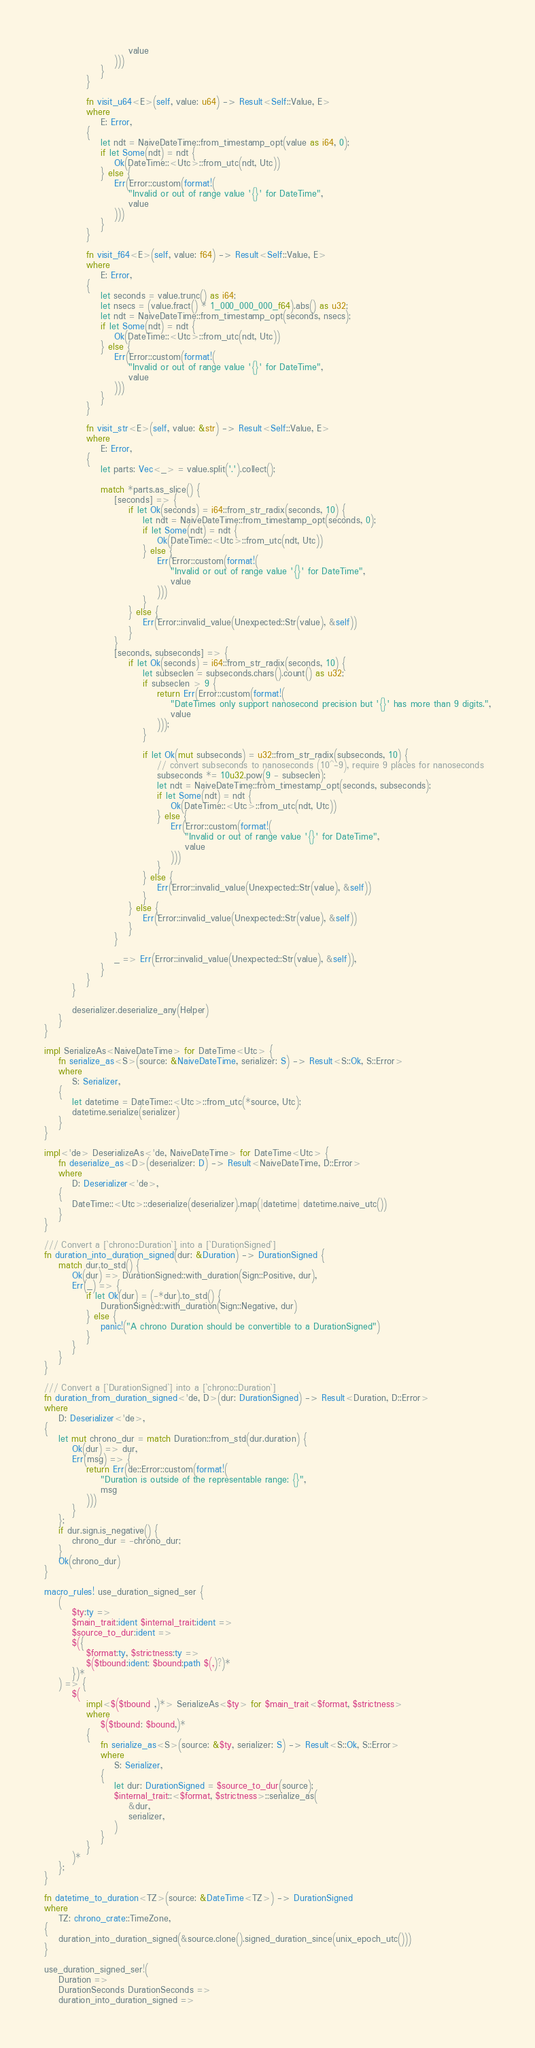<code> <loc_0><loc_0><loc_500><loc_500><_Rust_>                        value
                    )))
                }
            }

            fn visit_u64<E>(self, value: u64) -> Result<Self::Value, E>
            where
                E: Error,
            {
                let ndt = NaiveDateTime::from_timestamp_opt(value as i64, 0);
                if let Some(ndt) = ndt {
                    Ok(DateTime::<Utc>::from_utc(ndt, Utc))
                } else {
                    Err(Error::custom(format!(
                        "Invalid or out of range value '{}' for DateTime",
                        value
                    )))
                }
            }

            fn visit_f64<E>(self, value: f64) -> Result<Self::Value, E>
            where
                E: Error,
            {
                let seconds = value.trunc() as i64;
                let nsecs = (value.fract() * 1_000_000_000_f64).abs() as u32;
                let ndt = NaiveDateTime::from_timestamp_opt(seconds, nsecs);
                if let Some(ndt) = ndt {
                    Ok(DateTime::<Utc>::from_utc(ndt, Utc))
                } else {
                    Err(Error::custom(format!(
                        "Invalid or out of range value '{}' for DateTime",
                        value
                    )))
                }
            }

            fn visit_str<E>(self, value: &str) -> Result<Self::Value, E>
            where
                E: Error,
            {
                let parts: Vec<_> = value.split('.').collect();

                match *parts.as_slice() {
                    [seconds] => {
                        if let Ok(seconds) = i64::from_str_radix(seconds, 10) {
                            let ndt = NaiveDateTime::from_timestamp_opt(seconds, 0);
                            if let Some(ndt) = ndt {
                                Ok(DateTime::<Utc>::from_utc(ndt, Utc))
                            } else {
                                Err(Error::custom(format!(
                                    "Invalid or out of range value '{}' for DateTime",
                                    value
                                )))
                            }
                        } else {
                            Err(Error::invalid_value(Unexpected::Str(value), &self))
                        }
                    }
                    [seconds, subseconds] => {
                        if let Ok(seconds) = i64::from_str_radix(seconds, 10) {
                            let subseclen = subseconds.chars().count() as u32;
                            if subseclen > 9 {
                                return Err(Error::custom(format!(
                                    "DateTimes only support nanosecond precision but '{}' has more than 9 digits.",
                                    value
                                )));
                            }

                            if let Ok(mut subseconds) = u32::from_str_radix(subseconds, 10) {
                                // convert subseconds to nanoseconds (10^-9), require 9 places for nanoseconds
                                subseconds *= 10u32.pow(9 - subseclen);
                                let ndt = NaiveDateTime::from_timestamp_opt(seconds, subseconds);
                                if let Some(ndt) = ndt {
                                    Ok(DateTime::<Utc>::from_utc(ndt, Utc))
                                } else {
                                    Err(Error::custom(format!(
                                        "Invalid or out of range value '{}' for DateTime",
                                        value
                                    )))
                                }
                            } else {
                                Err(Error::invalid_value(Unexpected::Str(value), &self))
                            }
                        } else {
                            Err(Error::invalid_value(Unexpected::Str(value), &self))
                        }
                    }

                    _ => Err(Error::invalid_value(Unexpected::Str(value), &self)),
                }
            }
        }

        deserializer.deserialize_any(Helper)
    }
}

impl SerializeAs<NaiveDateTime> for DateTime<Utc> {
    fn serialize_as<S>(source: &NaiveDateTime, serializer: S) -> Result<S::Ok, S::Error>
    where
        S: Serializer,
    {
        let datetime = DateTime::<Utc>::from_utc(*source, Utc);
        datetime.serialize(serializer)
    }
}

impl<'de> DeserializeAs<'de, NaiveDateTime> for DateTime<Utc> {
    fn deserialize_as<D>(deserializer: D) -> Result<NaiveDateTime, D::Error>
    where
        D: Deserializer<'de>,
    {
        DateTime::<Utc>::deserialize(deserializer).map(|datetime| datetime.naive_utc())
    }
}

/// Convert a [`chrono::Duration`] into a [`DurationSigned`]
fn duration_into_duration_signed(dur: &Duration) -> DurationSigned {
    match dur.to_std() {
        Ok(dur) => DurationSigned::with_duration(Sign::Positive, dur),
        Err(_) => {
            if let Ok(dur) = (-*dur).to_std() {
                DurationSigned::with_duration(Sign::Negative, dur)
            } else {
                panic!("A chrono Duration should be convertible to a DurationSigned")
            }
        }
    }
}

/// Convert a [`DurationSigned`] into a [`chrono::Duration`]
fn duration_from_duration_signed<'de, D>(dur: DurationSigned) -> Result<Duration, D::Error>
where
    D: Deserializer<'de>,
{
    let mut chrono_dur = match Duration::from_std(dur.duration) {
        Ok(dur) => dur,
        Err(msg) => {
            return Err(de::Error::custom(format!(
                "Duration is outside of the representable range: {}",
                msg
            )))
        }
    };
    if dur.sign.is_negative() {
        chrono_dur = -chrono_dur;
    }
    Ok(chrono_dur)
}

macro_rules! use_duration_signed_ser {
    (
        $ty:ty =>
        $main_trait:ident $internal_trait:ident =>
        $source_to_dur:ident =>
        $({
            $format:ty, $strictness:ty =>
            $($tbound:ident: $bound:path $(,)?)*
        })*
    ) => {
        $(
            impl<$($tbound ,)*> SerializeAs<$ty> for $main_trait<$format, $strictness>
            where
                $($tbound: $bound,)*
            {
                fn serialize_as<S>(source: &$ty, serializer: S) -> Result<S::Ok, S::Error>
                where
                    S: Serializer,
                {
                    let dur: DurationSigned = $source_to_dur(source);
                    $internal_trait::<$format, $strictness>::serialize_as(
                        &dur,
                        serializer,
                    )
                }
            }
        )*
    };
}

fn datetime_to_duration<TZ>(source: &DateTime<TZ>) -> DurationSigned
where
    TZ: chrono_crate::TimeZone,
{
    duration_into_duration_signed(&source.clone().signed_duration_since(unix_epoch_utc()))
}

use_duration_signed_ser!(
    Duration =>
    DurationSeconds DurationSeconds =>
    duration_into_duration_signed =></code> 